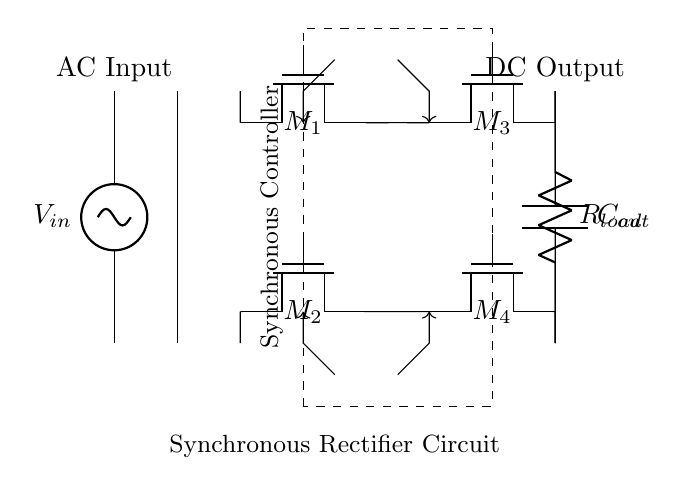What type of rectifier is used in this circuit? This circuit uses a synchronous rectifier, which employs MOSFETs instead of traditional diodes for rectification purposes. The presence of multiple MOSFETs indicates that the rectification is synchronous in nature.
Answer: synchronous How many MOSFETs are present in the circuit? The circuit displays four MOSFETs labeled M1, M2, M3, and M4, as indicated in the schematic.
Answer: four What is the role of the transformer in this circuit? The transformer performs the function of stepping down or isolating the AC voltage from the input source before the rectification process. Its location in the circuit indicates an input AC source requiring transformation.
Answer: voltage transformation What component is indicated by the label C out? The label C out designates a capacitor connected at the output, used for filtering purposes to smooth out the rectified DC voltage. This is a typical function for capacitors in rectifier circuits.
Answer: capacitor What is the load connected to the output of this circuit? The load is represented by R load, typically indicating a resistive load connected to the output that consumes the supplied DC power. The label clearly identifies it as a resistor.
Answer: resistor How does the synchronous controller affect the efficiency of the circuit? The synchronous controller optimizes the switching of the MOSFETs to minimize conduction losses during the rectification process, thus improving overall efficiency compared to traditional diode rectification. This functionality is due to the active control of the MOSFET gate signals.
Answer: improves efficiency 